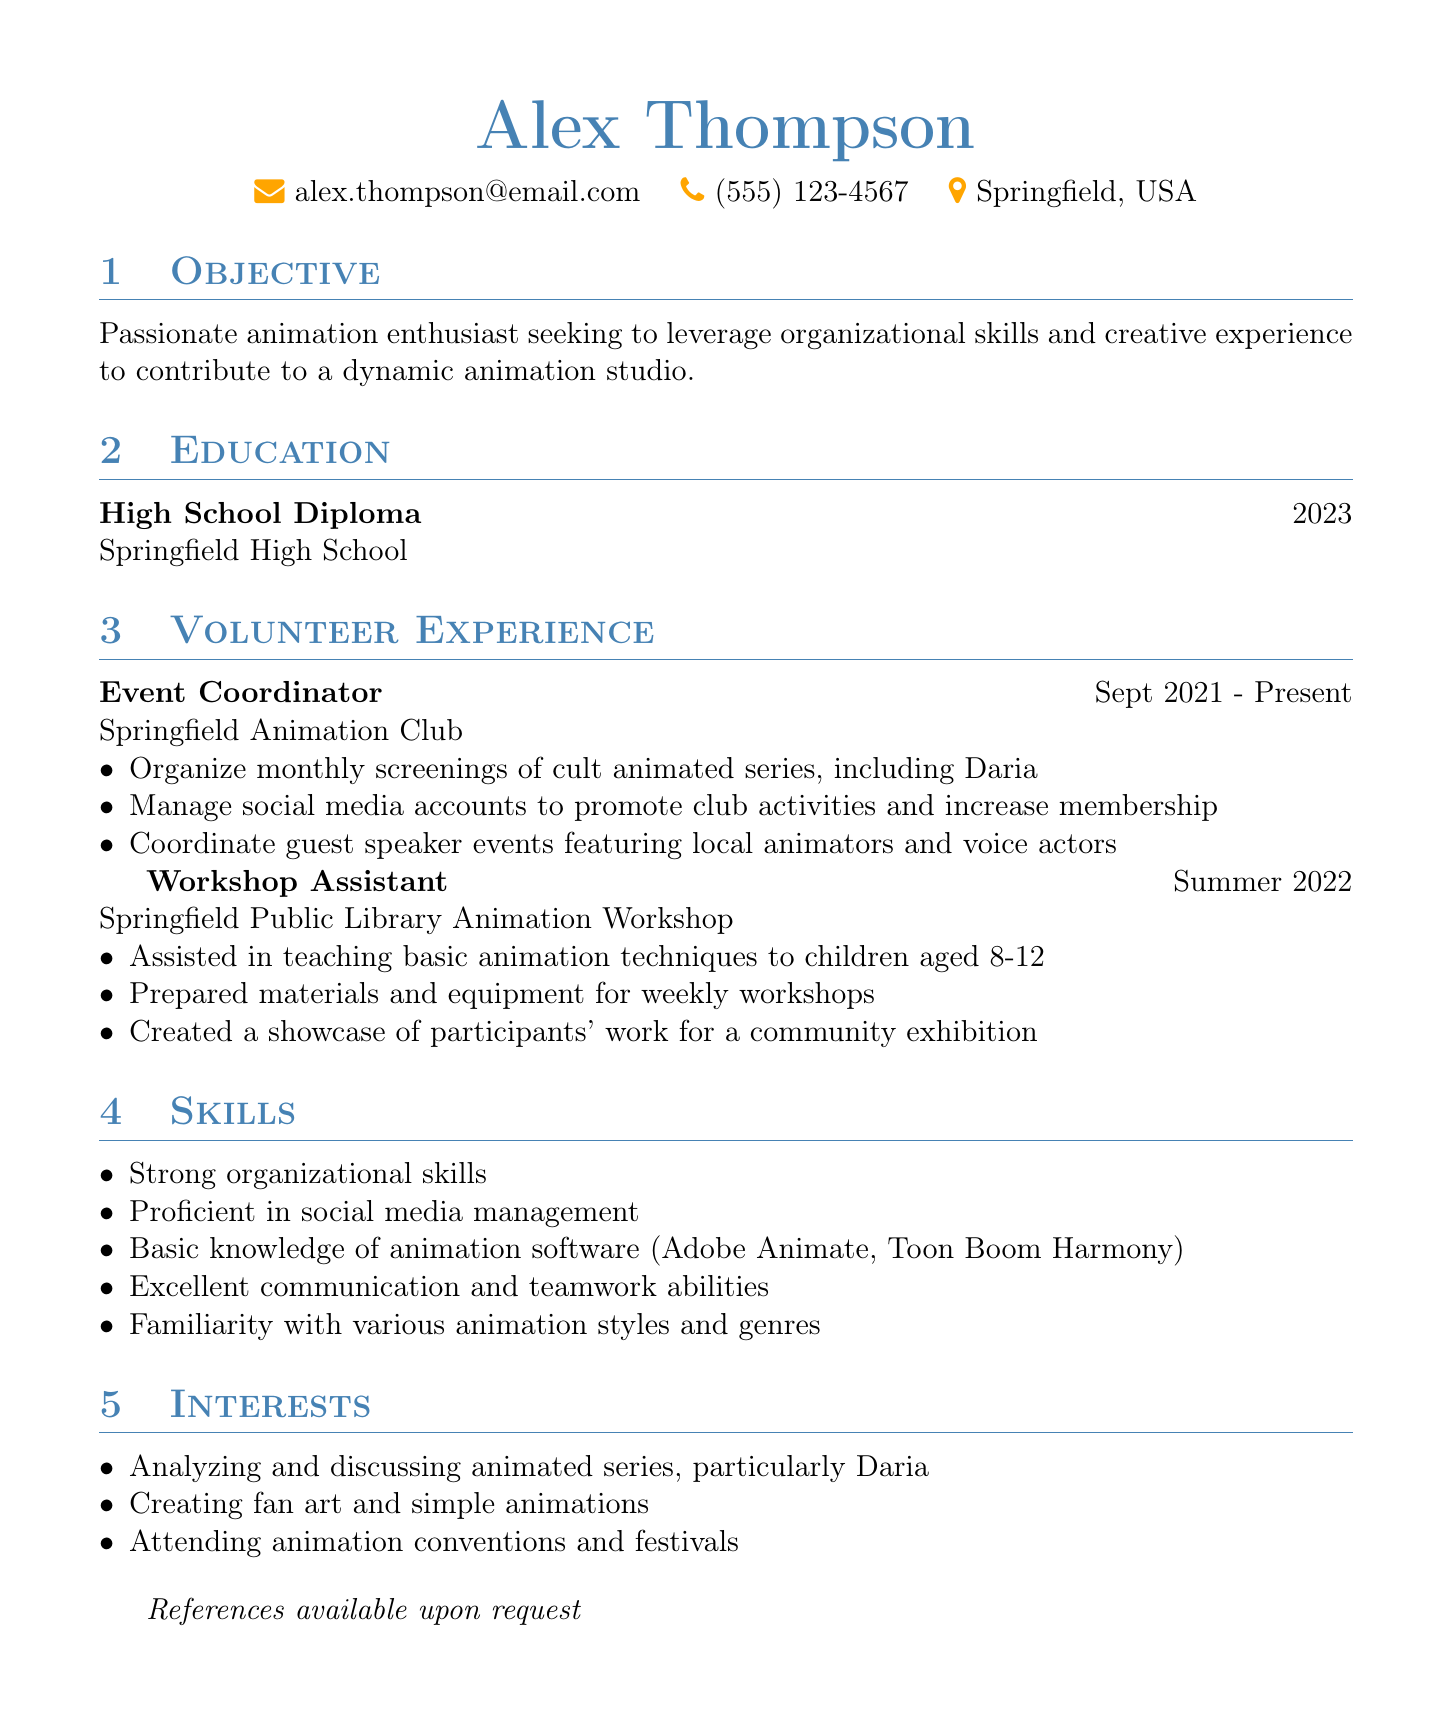what is the name of the individual in the resume? The individual's name is mentioned at the top of the document.
Answer: Alex Thompson what is the email address listed in the resume? The email address can be found in the personal information section.
Answer: alex.thompson@email.com what organization did Alex volunteer as an Event Coordinator? The organization is specified in the volunteer experience section.
Answer: Springfield Animation Club when did Alex start volunteering at the Springfield Animation Club? The start date is indicated in the volunteer experience details.
Answer: Sept 2021 how long did Alex work as a Workshop Assistant? The duration of this position is stated in the volunteer experience.
Answer: Summer 2022 what skills does Alex possess related to social media? Skills are listed under the skills section of the resume.
Answer: Proficient in social media management which animated series does Alex mention analyzing and discussing? This is mentioned under the interests section.
Answer: Daria what type of degree does Alex hold? The degree is clearly stated in the education section.
Answer: High School Diploma what responsibilities did Alex have in coordinating guest speaker events? Responsibilities are outlined in the volunteer experience for the Event Coordinator position.
Answer: Coordinate guest speaker events featuring local animators and voice actors 